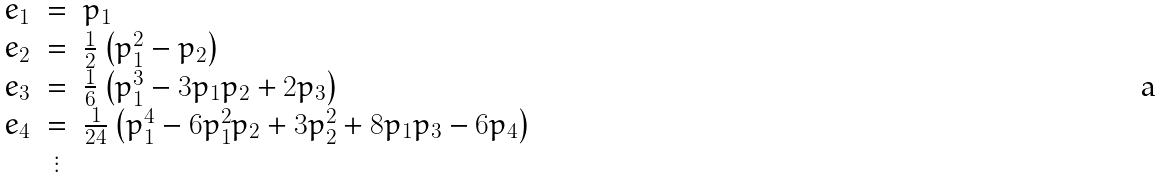Convert formula to latex. <formula><loc_0><loc_0><loc_500><loc_500>\begin{array} { c c l } e _ { 1 } & = & p _ { 1 } \\ e _ { 2 } & = & \frac { 1 } { 2 } \left ( p _ { 1 } ^ { 2 } - p _ { 2 } \right ) \\ e _ { 3 } & = & \frac { 1 } { 6 } \left ( p _ { 1 } ^ { 3 } - 3 p _ { 1 } p _ { 2 } + 2 p _ { 3 } \right ) \\ e _ { 4 } & = & \frac { 1 } { 2 4 } \left ( p _ { 1 } ^ { 4 } - 6 p _ { 1 } ^ { 2 } p _ { 2 } + 3 p _ { 2 } ^ { 2 } + 8 p _ { 1 } p _ { 3 } - 6 p _ { 4 } \right ) \\ & \vdots & \\ \end{array}</formula> 